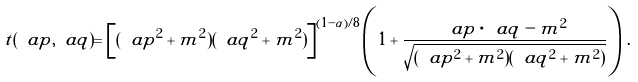Convert formula to latex. <formula><loc_0><loc_0><loc_500><loc_500>t ( \ a p , \ a q ) = \left [ ( \ a p ^ { 2 } + m ^ { 2 } ) ( \ a q ^ { 2 } + m ^ { 2 } ) \right ] ^ { ( 1 - \alpha ) / 8 } \left ( 1 + \frac { \ a p \cdot \ a q - m ^ { 2 } } { \sqrt { ( \ a p ^ { 2 } + m ^ { 2 } ) ( \ a q ^ { 2 } + m ^ { 2 } ) } } \right ) \, .</formula> 